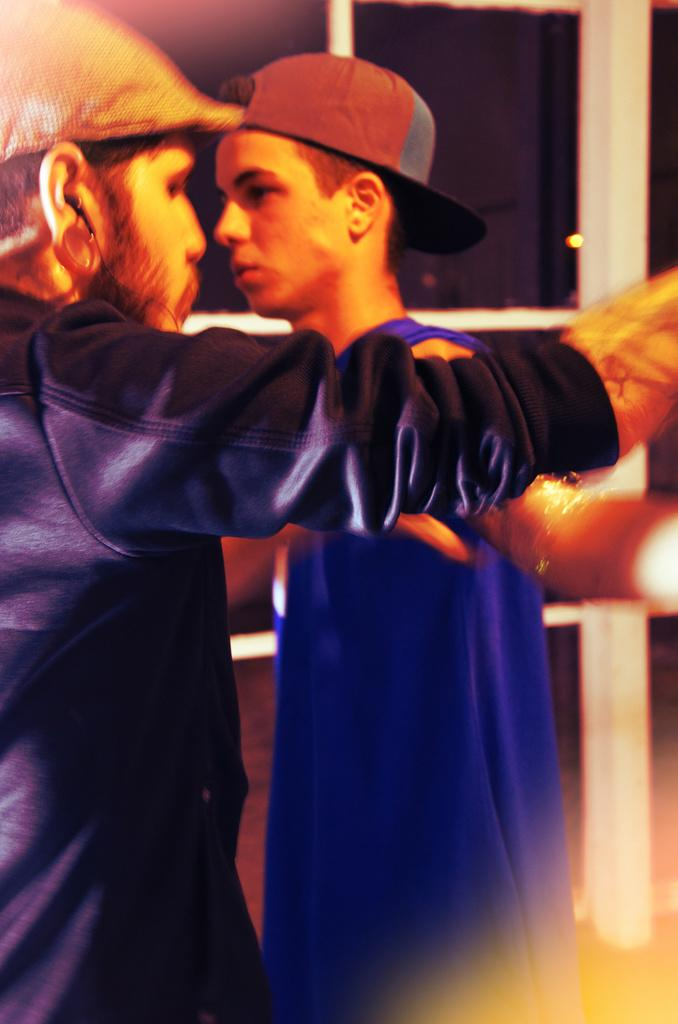What is the main subject in the center of the image? There is a person standing in the center of the image. What is the person in the center wearing? The person in the center is wearing a hat. Who else is present in the image? There is a man standing on the left side of the image. What is the man on the left wearing? The man on the left is wearing a hat and a headset. What type of juice is being served to the actor in the image? There is no actor or juice present in the image. How does the throat of the person in the center feel in the image? There is no information about the person's throat in the image, so it cannot be determined how they feel. 